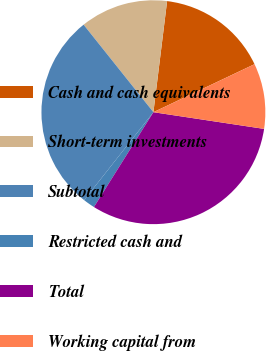Convert chart to OTSL. <chart><loc_0><loc_0><loc_500><loc_500><pie_chart><fcel>Cash and cash equivalents<fcel>Short-term investments<fcel>Subtotal<fcel>Restricted cash and<fcel>Total<fcel>Working capital from<nl><fcel>15.99%<fcel>12.67%<fcel>28.66%<fcel>1.71%<fcel>31.53%<fcel>9.44%<nl></chart> 